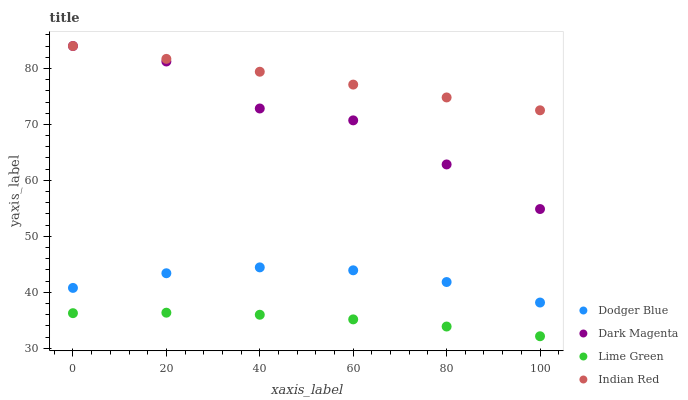Does Lime Green have the minimum area under the curve?
Answer yes or no. Yes. Does Indian Red have the maximum area under the curve?
Answer yes or no. Yes. Does Dodger Blue have the minimum area under the curve?
Answer yes or no. No. Does Dodger Blue have the maximum area under the curve?
Answer yes or no. No. Is Indian Red the smoothest?
Answer yes or no. Yes. Is Dark Magenta the roughest?
Answer yes or no. Yes. Is Dodger Blue the smoothest?
Answer yes or no. No. Is Dodger Blue the roughest?
Answer yes or no. No. Does Lime Green have the lowest value?
Answer yes or no. Yes. Does Dodger Blue have the lowest value?
Answer yes or no. No. Does Indian Red have the highest value?
Answer yes or no. Yes. Does Dodger Blue have the highest value?
Answer yes or no. No. Is Lime Green less than Indian Red?
Answer yes or no. Yes. Is Dark Magenta greater than Dodger Blue?
Answer yes or no. Yes. Does Dark Magenta intersect Indian Red?
Answer yes or no. Yes. Is Dark Magenta less than Indian Red?
Answer yes or no. No. Is Dark Magenta greater than Indian Red?
Answer yes or no. No. Does Lime Green intersect Indian Red?
Answer yes or no. No. 